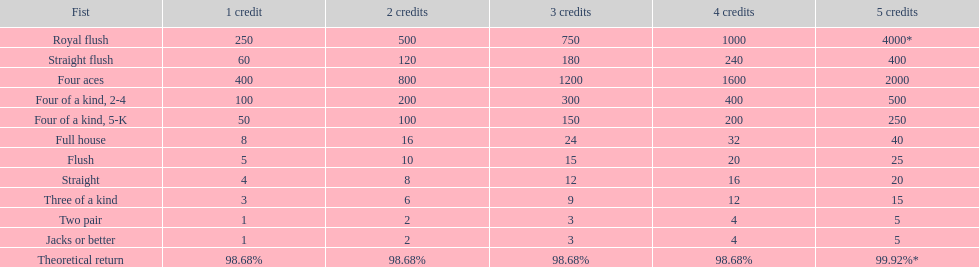After winning on four credits with a full house, what is your payout? 32. 